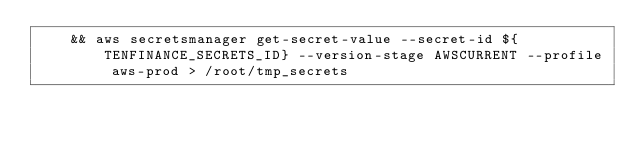<code> <loc_0><loc_0><loc_500><loc_500><_Bash_>    && aws secretsmanager get-secret-value --secret-id ${TENFINANCE_SECRETS_ID} --version-stage AWSCURRENT --profile aws-prod > /root/tmp_secrets
</code> 